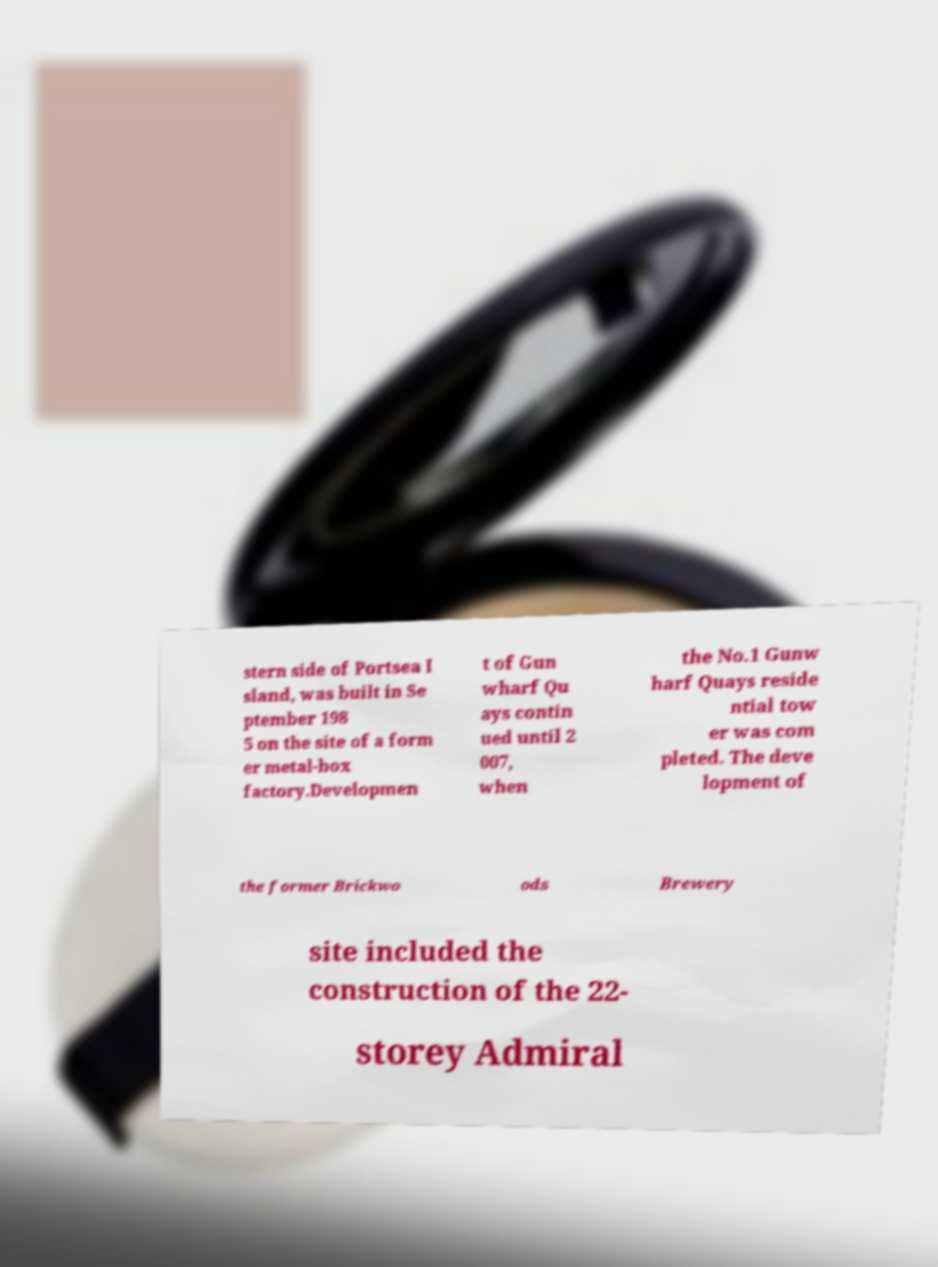Can you accurately transcribe the text from the provided image for me? stern side of Portsea I sland, was built in Se ptember 198 5 on the site of a form er metal-box factory.Developmen t of Gun wharf Qu ays contin ued until 2 007, when the No.1 Gunw harf Quays reside ntial tow er was com pleted. The deve lopment of the former Brickwo ods Brewery site included the construction of the 22- storey Admiral 